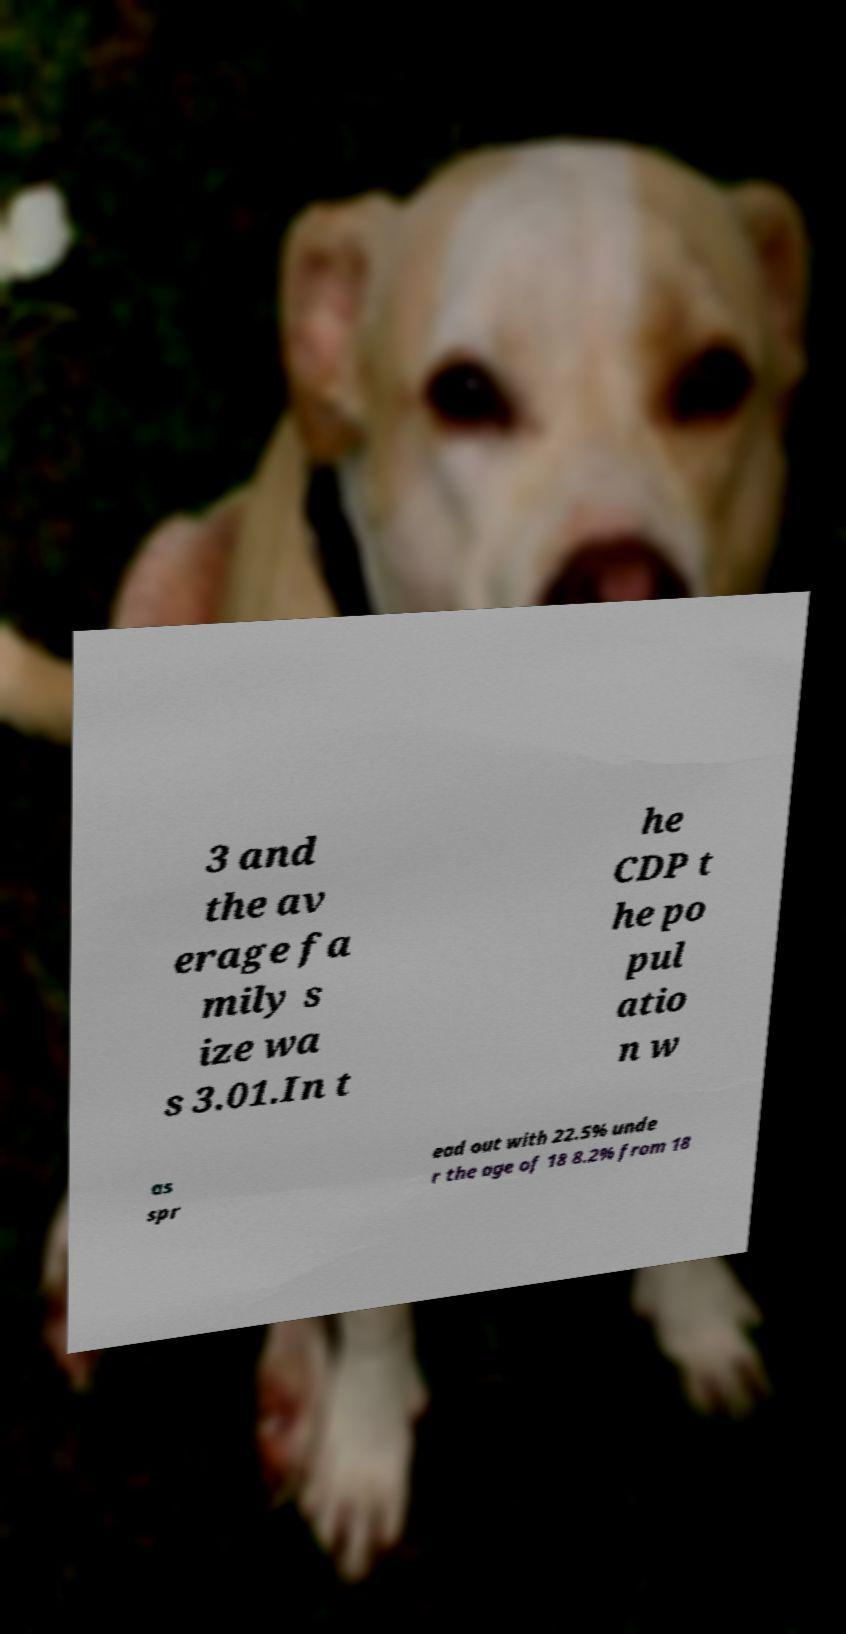I need the written content from this picture converted into text. Can you do that? 3 and the av erage fa mily s ize wa s 3.01.In t he CDP t he po pul atio n w as spr ead out with 22.5% unde r the age of 18 8.2% from 18 